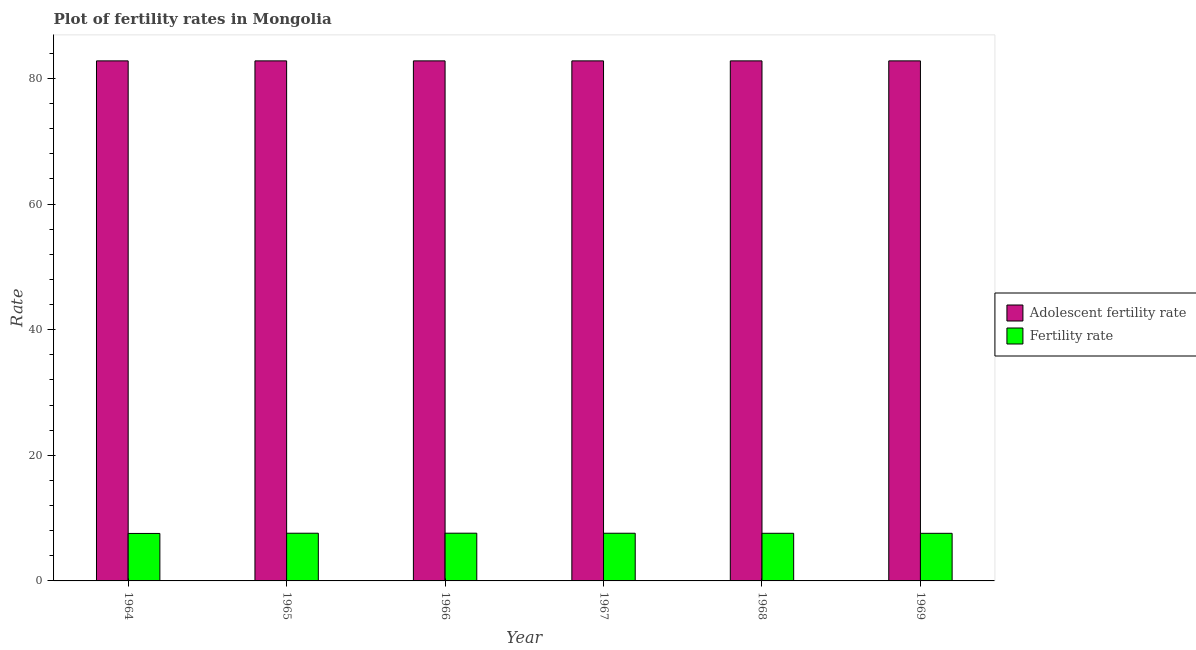How many groups of bars are there?
Offer a terse response. 6. Are the number of bars on each tick of the X-axis equal?
Your answer should be compact. Yes. What is the label of the 1st group of bars from the left?
Keep it short and to the point. 1964. What is the fertility rate in 1969?
Your answer should be compact. 7.58. Across all years, what is the maximum adolescent fertility rate?
Offer a terse response. 82.8. Across all years, what is the minimum adolescent fertility rate?
Offer a very short reply. 82.8. In which year was the fertility rate maximum?
Your answer should be very brief. 1966. In which year was the adolescent fertility rate minimum?
Offer a terse response. 1964. What is the total fertility rate in the graph?
Keep it short and to the point. 45.5. What is the difference between the fertility rate in 1964 and that in 1966?
Ensure brevity in your answer.  -0.04. What is the difference between the adolescent fertility rate in 1969 and the fertility rate in 1965?
Provide a succinct answer. 0. What is the average fertility rate per year?
Make the answer very short. 7.58. In how many years, is the fertility rate greater than 76?
Make the answer very short. 0. What is the ratio of the fertility rate in 1964 to that in 1965?
Give a very brief answer. 1. What is the difference between the highest and the second highest fertility rate?
Your answer should be compact. 0.01. What does the 2nd bar from the left in 1967 represents?
Offer a very short reply. Fertility rate. What does the 2nd bar from the right in 1964 represents?
Give a very brief answer. Adolescent fertility rate. How many bars are there?
Offer a terse response. 12. How many years are there in the graph?
Ensure brevity in your answer.  6. How many legend labels are there?
Make the answer very short. 2. What is the title of the graph?
Your answer should be very brief. Plot of fertility rates in Mongolia. What is the label or title of the Y-axis?
Keep it short and to the point. Rate. What is the Rate of Adolescent fertility rate in 1964?
Your answer should be compact. 82.8. What is the Rate in Fertility rate in 1964?
Provide a short and direct response. 7.56. What is the Rate in Adolescent fertility rate in 1965?
Keep it short and to the point. 82.8. What is the Rate of Fertility rate in 1965?
Keep it short and to the point. 7.59. What is the Rate in Adolescent fertility rate in 1966?
Ensure brevity in your answer.  82.8. What is the Rate of Fertility rate in 1966?
Offer a very short reply. 7.6. What is the Rate of Adolescent fertility rate in 1967?
Your response must be concise. 82.8. What is the Rate of Fertility rate in 1967?
Give a very brief answer. 7.59. What is the Rate of Adolescent fertility rate in 1968?
Offer a very short reply. 82.8. What is the Rate in Fertility rate in 1968?
Give a very brief answer. 7.58. What is the Rate of Adolescent fertility rate in 1969?
Ensure brevity in your answer.  82.8. What is the Rate of Fertility rate in 1969?
Your answer should be compact. 7.58. Across all years, what is the maximum Rate of Adolescent fertility rate?
Your response must be concise. 82.8. Across all years, what is the maximum Rate of Fertility rate?
Offer a terse response. 7.6. Across all years, what is the minimum Rate in Adolescent fertility rate?
Offer a terse response. 82.8. Across all years, what is the minimum Rate of Fertility rate?
Your response must be concise. 7.56. What is the total Rate of Adolescent fertility rate in the graph?
Your response must be concise. 496.81. What is the total Rate of Fertility rate in the graph?
Make the answer very short. 45.5. What is the difference between the Rate in Fertility rate in 1964 and that in 1965?
Provide a succinct answer. -0.04. What is the difference between the Rate in Fertility rate in 1964 and that in 1966?
Provide a succinct answer. -0.04. What is the difference between the Rate in Fertility rate in 1964 and that in 1967?
Provide a succinct answer. -0.03. What is the difference between the Rate in Adolescent fertility rate in 1964 and that in 1968?
Ensure brevity in your answer.  0. What is the difference between the Rate of Fertility rate in 1964 and that in 1968?
Provide a succinct answer. -0.03. What is the difference between the Rate of Adolescent fertility rate in 1964 and that in 1969?
Offer a very short reply. 0. What is the difference between the Rate in Fertility rate in 1964 and that in 1969?
Offer a very short reply. -0.02. What is the difference between the Rate in Adolescent fertility rate in 1965 and that in 1966?
Your answer should be very brief. 0. What is the difference between the Rate in Fertility rate in 1965 and that in 1966?
Make the answer very short. -0.01. What is the difference between the Rate of Fertility rate in 1965 and that in 1967?
Your answer should be very brief. 0. What is the difference between the Rate of Adolescent fertility rate in 1965 and that in 1968?
Your answer should be compact. 0. What is the difference between the Rate in Fertility rate in 1965 and that in 1968?
Your response must be concise. 0.01. What is the difference between the Rate of Fertility rate in 1965 and that in 1969?
Your answer should be very brief. 0.01. What is the difference between the Rate of Fertility rate in 1966 and that in 1967?
Give a very brief answer. 0.01. What is the difference between the Rate in Adolescent fertility rate in 1966 and that in 1968?
Your answer should be compact. 0. What is the difference between the Rate in Fertility rate in 1966 and that in 1968?
Offer a very short reply. 0.01. What is the difference between the Rate of Fertility rate in 1966 and that in 1969?
Ensure brevity in your answer.  0.02. What is the difference between the Rate in Fertility rate in 1967 and that in 1968?
Your response must be concise. 0.01. What is the difference between the Rate in Fertility rate in 1967 and that in 1969?
Your response must be concise. 0.01. What is the difference between the Rate of Adolescent fertility rate in 1968 and that in 1969?
Ensure brevity in your answer.  0. What is the difference between the Rate of Fertility rate in 1968 and that in 1969?
Provide a short and direct response. 0.01. What is the difference between the Rate of Adolescent fertility rate in 1964 and the Rate of Fertility rate in 1965?
Your response must be concise. 75.21. What is the difference between the Rate of Adolescent fertility rate in 1964 and the Rate of Fertility rate in 1966?
Provide a succinct answer. 75.2. What is the difference between the Rate of Adolescent fertility rate in 1964 and the Rate of Fertility rate in 1967?
Your answer should be very brief. 75.21. What is the difference between the Rate in Adolescent fertility rate in 1964 and the Rate in Fertility rate in 1968?
Ensure brevity in your answer.  75.22. What is the difference between the Rate of Adolescent fertility rate in 1964 and the Rate of Fertility rate in 1969?
Make the answer very short. 75.22. What is the difference between the Rate of Adolescent fertility rate in 1965 and the Rate of Fertility rate in 1966?
Keep it short and to the point. 75.2. What is the difference between the Rate in Adolescent fertility rate in 1965 and the Rate in Fertility rate in 1967?
Your response must be concise. 75.21. What is the difference between the Rate of Adolescent fertility rate in 1965 and the Rate of Fertility rate in 1968?
Offer a terse response. 75.22. What is the difference between the Rate in Adolescent fertility rate in 1965 and the Rate in Fertility rate in 1969?
Provide a short and direct response. 75.22. What is the difference between the Rate of Adolescent fertility rate in 1966 and the Rate of Fertility rate in 1967?
Make the answer very short. 75.21. What is the difference between the Rate in Adolescent fertility rate in 1966 and the Rate in Fertility rate in 1968?
Offer a terse response. 75.22. What is the difference between the Rate in Adolescent fertility rate in 1966 and the Rate in Fertility rate in 1969?
Your answer should be very brief. 75.22. What is the difference between the Rate in Adolescent fertility rate in 1967 and the Rate in Fertility rate in 1968?
Provide a short and direct response. 75.22. What is the difference between the Rate of Adolescent fertility rate in 1967 and the Rate of Fertility rate in 1969?
Your answer should be compact. 75.22. What is the difference between the Rate in Adolescent fertility rate in 1968 and the Rate in Fertility rate in 1969?
Ensure brevity in your answer.  75.22. What is the average Rate in Adolescent fertility rate per year?
Offer a very short reply. 82.8. What is the average Rate of Fertility rate per year?
Your answer should be compact. 7.58. In the year 1964, what is the difference between the Rate of Adolescent fertility rate and Rate of Fertility rate?
Keep it short and to the point. 75.24. In the year 1965, what is the difference between the Rate of Adolescent fertility rate and Rate of Fertility rate?
Your response must be concise. 75.21. In the year 1966, what is the difference between the Rate of Adolescent fertility rate and Rate of Fertility rate?
Offer a terse response. 75.2. In the year 1967, what is the difference between the Rate of Adolescent fertility rate and Rate of Fertility rate?
Offer a terse response. 75.21. In the year 1968, what is the difference between the Rate in Adolescent fertility rate and Rate in Fertility rate?
Your answer should be very brief. 75.22. In the year 1969, what is the difference between the Rate in Adolescent fertility rate and Rate in Fertility rate?
Your answer should be compact. 75.22. What is the ratio of the Rate in Fertility rate in 1964 to that in 1968?
Your answer should be compact. 1. What is the ratio of the Rate in Adolescent fertility rate in 1964 to that in 1969?
Ensure brevity in your answer.  1. What is the ratio of the Rate in Adolescent fertility rate in 1965 to that in 1966?
Your answer should be very brief. 1. What is the ratio of the Rate in Fertility rate in 1965 to that in 1966?
Ensure brevity in your answer.  1. What is the ratio of the Rate in Adolescent fertility rate in 1965 to that in 1967?
Ensure brevity in your answer.  1. What is the ratio of the Rate in Adolescent fertility rate in 1965 to that in 1968?
Your response must be concise. 1. What is the ratio of the Rate in Adolescent fertility rate in 1965 to that in 1969?
Give a very brief answer. 1. What is the ratio of the Rate of Fertility rate in 1965 to that in 1969?
Give a very brief answer. 1. What is the ratio of the Rate of Fertility rate in 1966 to that in 1967?
Provide a short and direct response. 1. What is the ratio of the Rate in Adolescent fertility rate in 1966 to that in 1968?
Your answer should be compact. 1. What is the ratio of the Rate of Adolescent fertility rate in 1967 to that in 1968?
Keep it short and to the point. 1. What is the ratio of the Rate in Fertility rate in 1967 to that in 1968?
Your answer should be very brief. 1. What is the difference between the highest and the second highest Rate of Fertility rate?
Give a very brief answer. 0.01. What is the difference between the highest and the lowest Rate in Fertility rate?
Offer a terse response. 0.04. 